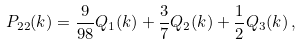Convert formula to latex. <formula><loc_0><loc_0><loc_500><loc_500>P _ { 2 2 } ( k ) = \frac { 9 } { 9 8 } Q _ { 1 } ( k ) + \frac { 3 } { 7 } Q _ { 2 } ( k ) + \frac { 1 } { 2 } Q _ { 3 } ( k ) \, ,</formula> 